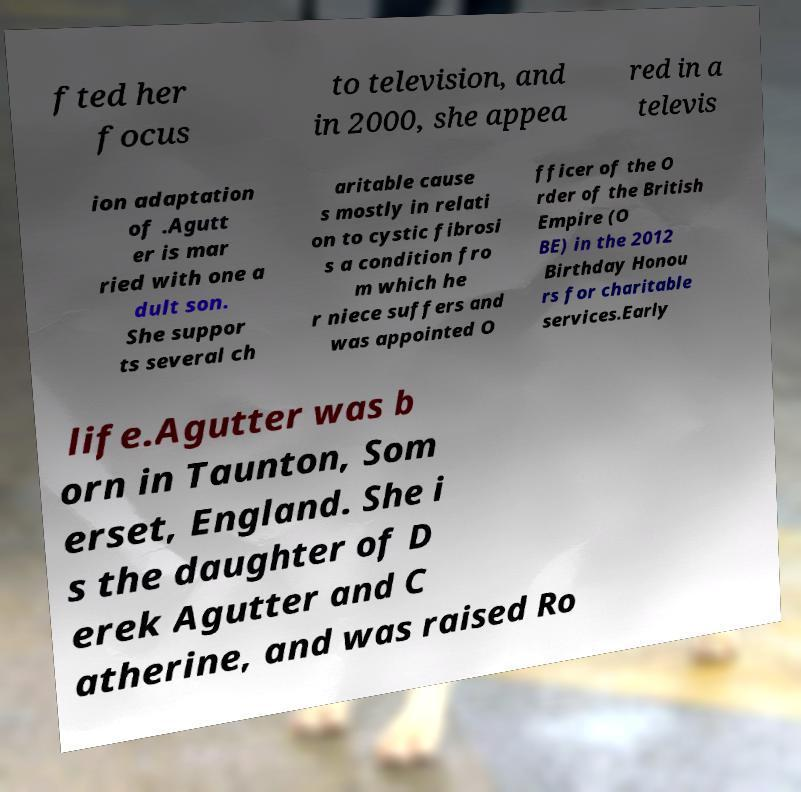There's text embedded in this image that I need extracted. Can you transcribe it verbatim? fted her focus to television, and in 2000, she appea red in a televis ion adaptation of .Agutt er is mar ried with one a dult son. She suppor ts several ch aritable cause s mostly in relati on to cystic fibrosi s a condition fro m which he r niece suffers and was appointed O fficer of the O rder of the British Empire (O BE) in the 2012 Birthday Honou rs for charitable services.Early life.Agutter was b orn in Taunton, Som erset, England. She i s the daughter of D erek Agutter and C atherine, and was raised Ro 